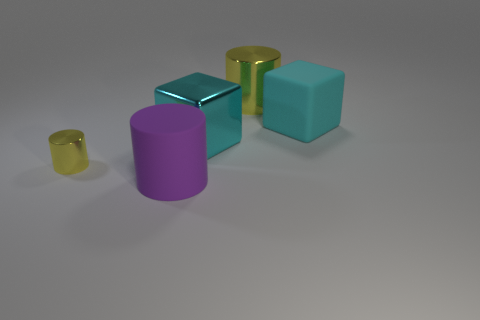There is another object that is the same shape as the cyan matte object; what is its material? The object that shares its shape with the cyan matte object is another cube that appears to be made of glossy metal, reflecting the environment and light in a way that is characteristic of metallic surfaces. 